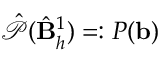<formula> <loc_0><loc_0><loc_500><loc_500>\hat { \mathcal { P } } ( \hat { B } _ { h } ^ { 1 } ) = \colon P ( b )</formula> 